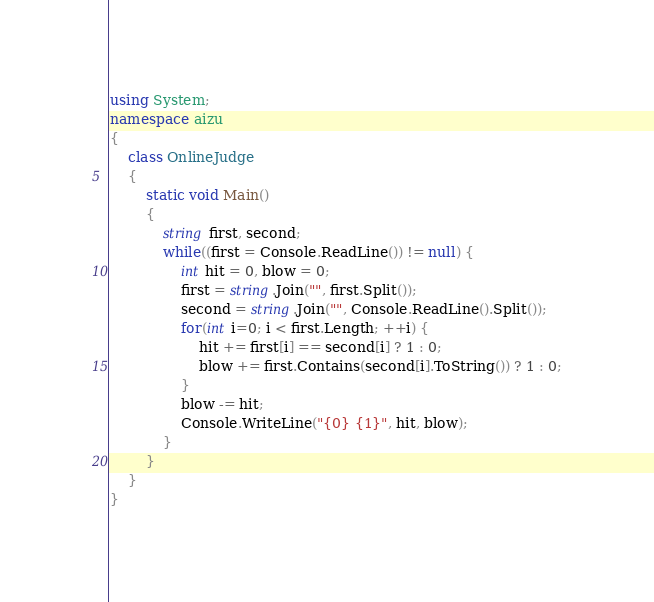<code> <loc_0><loc_0><loc_500><loc_500><_C#_>using System;
namespace aizu
{
    class OnlineJudge
    {
        static void Main()
        {
            string first, second;
            while((first = Console.ReadLine()) != null) {
                int hit = 0, blow = 0;
                first = string.Join("", first.Split());
                second = string.Join("", Console.ReadLine().Split());
                for(int i=0; i < first.Length; ++i) {
                    hit += first[i] == second[i] ? 1 : 0;
                    blow += first.Contains(second[i].ToString()) ? 1 : 0;
                }
                blow -= hit;
                Console.WriteLine("{0} {1}", hit, blow);
            }
        }
    }
}</code> 